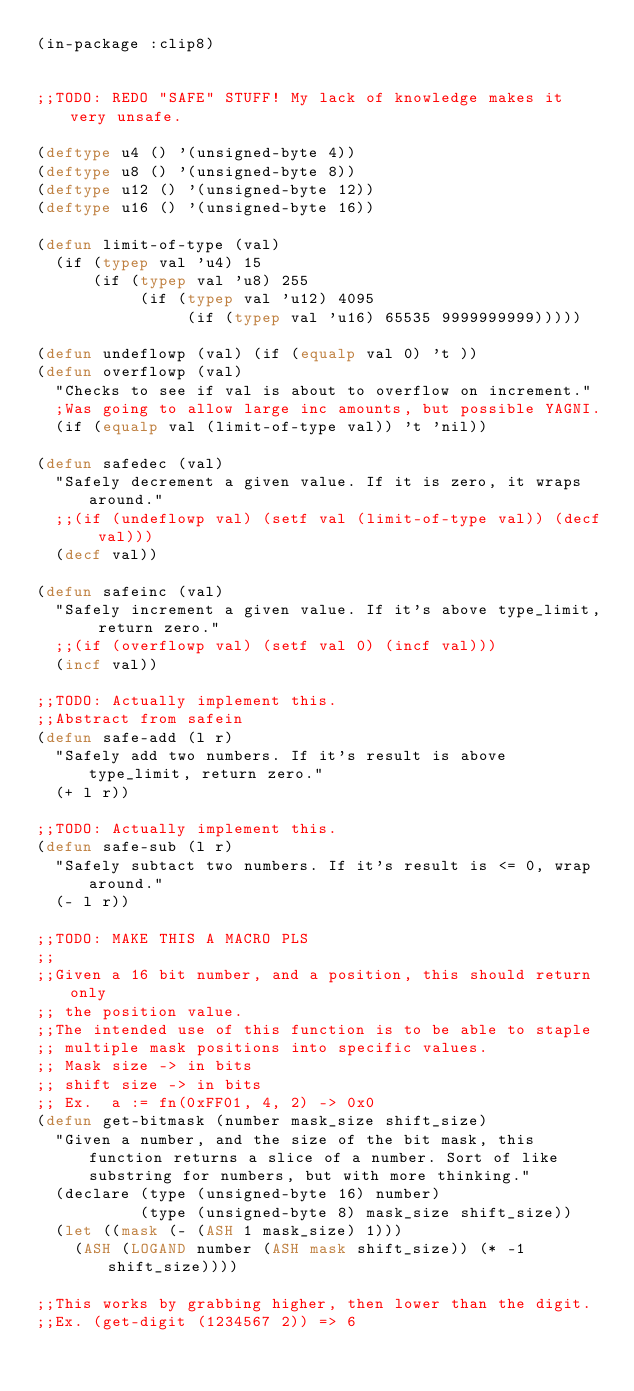Convert code to text. <code><loc_0><loc_0><loc_500><loc_500><_Lisp_>(in-package :clip8)


;;TODO: REDO "SAFE" STUFF! My lack of knowledge makes it very unsafe.

(deftype u4 () '(unsigned-byte 4))
(deftype u8 () '(unsigned-byte 8))
(deftype u12 () '(unsigned-byte 12))
(deftype u16 () '(unsigned-byte 16))

(defun limit-of-type (val)
  (if (typep val 'u4) 15
      (if (typep val 'u8) 255
           (if (typep val 'u12) 4095
                (if (typep val 'u16) 65535 9999999999)))))

(defun undeflowp (val) (if (equalp val 0) 't ))
(defun overflowp (val)
  "Checks to see if val is about to overflow on increment."
  ;Was going to allow large inc amounts, but possible YAGNI.
  (if (equalp val (limit-of-type val)) 't 'nil))
            
(defun safedec (val)
  "Safely decrement a given value. If it is zero, it wraps around."
  ;;(if (undeflowp val) (setf val (limit-of-type val)) (decf val)))
  (decf val))

(defun safeinc (val)
  "Safely increment a given value. If it's above type_limit, return zero."
  ;;(if (overflowp val) (setf val 0) (incf val)))
  (incf val))

;;TODO: Actually implement this.
;;Abstract from safein
(defun safe-add (l r)
  "Safely add two numbers. If it's result is above type_limit, return zero."
  (+ l r))

;;TODO: Actually implement this.
(defun safe-sub (l r)
  "Safely subtact two numbers. If it's result is <= 0, wrap around."
  (- l r))

;;TODO: MAKE THIS A MACRO PLS
;;
;;Given a 16 bit number, and a position, this should return only
;; the position value.
;;The intended use of this function is to be able to staple
;; multiple mask positions into specific values.
;; Mask size -> in bits
;; shift size -> in bits
;; Ex.  a := fn(0xFF01, 4, 2) -> 0x0
(defun get-bitmask (number mask_size shift_size)
  "Given a number, and the size of the bit mask, this function returns a slice of a number. Sort of like substring for numbers, but with more thinking."
  (declare (type (unsigned-byte 16) number)
           (type (unsigned-byte 8) mask_size shift_size))
  (let ((mask (- (ASH 1 mask_size) 1)))
    (ASH (LOGAND number (ASH mask shift_size)) (* -1 shift_size))))

;;This works by grabbing higher, then lower than the digit.
;;Ex. (get-digit (1234567 2)) => 6</code> 